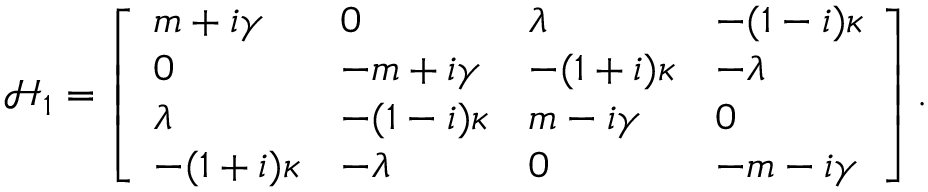Convert formula to latex. <formula><loc_0><loc_0><loc_500><loc_500>\begin{array} { r } { \mathcal { H } _ { 1 } = \left [ \begin{array} { l l l l } { m + i \gamma } & { 0 } & { \lambda } & { - ( 1 - i ) \kappa } \\ { 0 } & { - m + i \gamma } & { - ( 1 + i ) \kappa } & { - \lambda } \\ { \lambda } & { - ( 1 - i ) \kappa } & { m - i \gamma } & { 0 } \\ { - ( 1 + i ) \kappa } & { - \lambda } & { 0 } & { - m - i \gamma } \end{array} \right ] . } \end{array}</formula> 